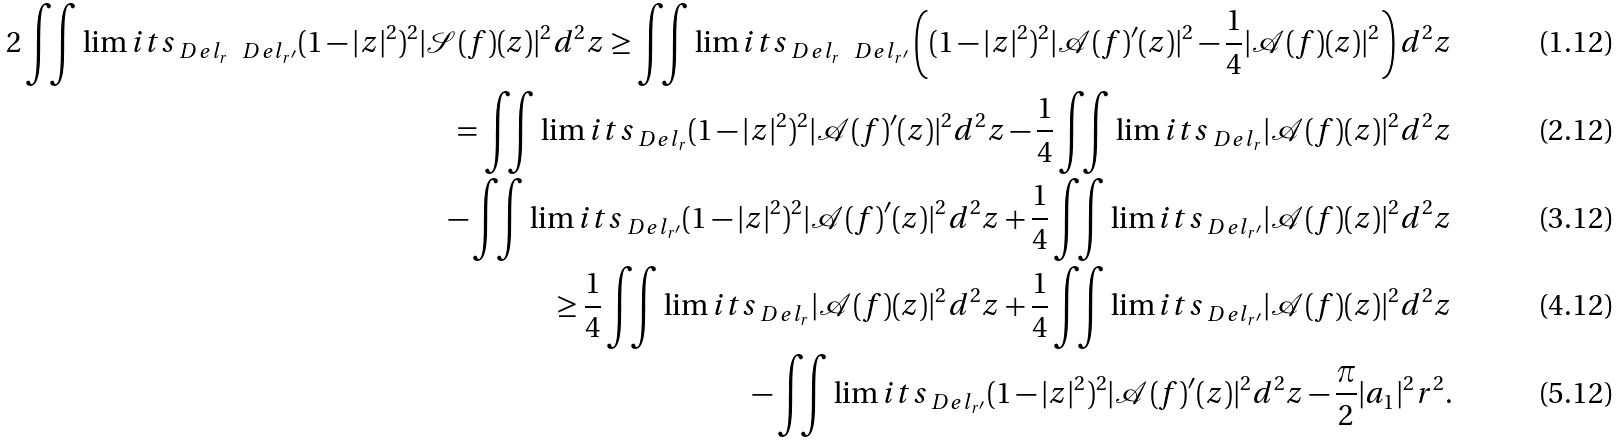Convert formula to latex. <formula><loc_0><loc_0><loc_500><loc_500>2 \iint \lim i t s _ { \ D e l _ { r } \ \ D e l _ { r ^ { \prime } } } ( 1 - | z | ^ { 2 } ) ^ { 2 } | \mathcal { S } ( f ) ( z ) | ^ { 2 } d ^ { 2 } z \geq \iint \lim i t s _ { \ D e l _ { r } \ \ D e l _ { r ^ { \prime } } } \left ( ( 1 - | z | ^ { 2 } ) ^ { 2 } | \mathcal { A } ( f ) ^ { \prime } ( z ) | ^ { 2 } - \frac { 1 } { 4 } | \mathcal { A } ( f ) ( z ) | ^ { 2 } \right ) d ^ { 2 } z \\ = \iint \lim i t s _ { \ D e l _ { r } } ( 1 - | z | ^ { 2 } ) ^ { 2 } | \mathcal { A } ( f ) ^ { \prime } ( z ) | ^ { 2 } d ^ { 2 } z - \frac { 1 } { 4 } \iint \lim i t s _ { \ D e l _ { r } } | \mathcal { A } ( f ) ( z ) | ^ { 2 } d ^ { 2 } z \\ - \iint \lim i t s _ { \ D e l _ { r ^ { \prime } } } ( 1 - | z | ^ { 2 } ) ^ { 2 } | \mathcal { A } ( f ) ^ { \prime } ( z ) | ^ { 2 } d ^ { 2 } z + \frac { 1 } { 4 } \iint \lim i t s _ { \ D e l _ { r ^ { \prime } } } | \mathcal { A } ( f ) ( z ) | ^ { 2 } d ^ { 2 } z \\ \geq \frac { 1 } { 4 } \iint \lim i t s _ { \ D e l _ { r } } | \mathcal { A } ( f ) ( z ) | ^ { 2 } d ^ { 2 } z + \frac { 1 } { 4 } \iint \lim i t s _ { \ D e l _ { r ^ { \prime } } } | \mathcal { A } ( f ) ( z ) | ^ { 2 } d ^ { 2 } z \\ - \iint \lim i t s _ { \ D e l _ { r ^ { \prime } } } ( 1 - | z | ^ { 2 } ) ^ { 2 } | \mathcal { A } ( f ) ^ { \prime } ( z ) | ^ { 2 } d ^ { 2 } z - \frac { \pi } { 2 } | a _ { 1 } | ^ { 2 } r ^ { 2 } .</formula> 